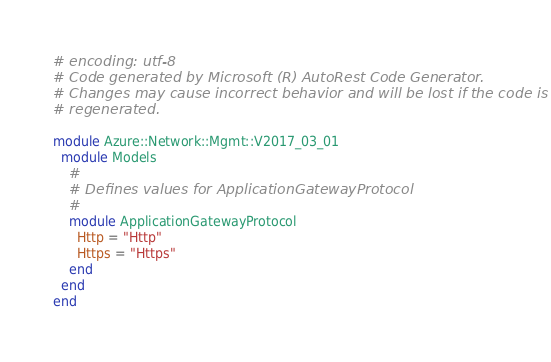<code> <loc_0><loc_0><loc_500><loc_500><_Ruby_># encoding: utf-8
# Code generated by Microsoft (R) AutoRest Code Generator.
# Changes may cause incorrect behavior and will be lost if the code is
# regenerated.

module Azure::Network::Mgmt::V2017_03_01
  module Models
    #
    # Defines values for ApplicationGatewayProtocol
    #
    module ApplicationGatewayProtocol
      Http = "Http"
      Https = "Https"
    end
  end
end
</code> 